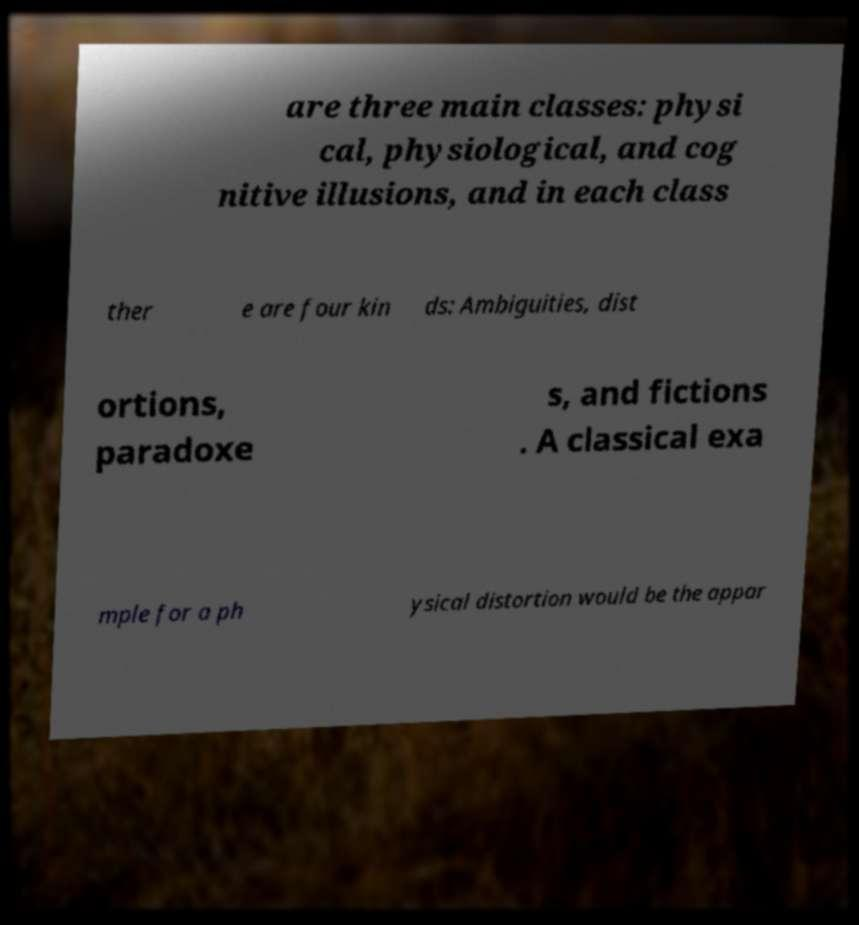Can you read and provide the text displayed in the image?This photo seems to have some interesting text. Can you extract and type it out for me? are three main classes: physi cal, physiological, and cog nitive illusions, and in each class ther e are four kin ds: Ambiguities, dist ortions, paradoxe s, and fictions . A classical exa mple for a ph ysical distortion would be the appar 